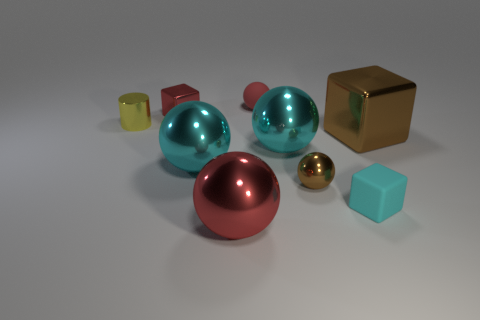Subtract all small brown shiny balls. How many balls are left? 4 Subtract all gray spheres. Subtract all cyan cubes. How many spheres are left? 5 Add 1 shiny cylinders. How many objects exist? 10 Subtract all cylinders. How many objects are left? 8 Subtract all gray spheres. Subtract all tiny red objects. How many objects are left? 7 Add 2 brown spheres. How many brown spheres are left? 3 Add 7 cyan rubber blocks. How many cyan rubber blocks exist? 8 Subtract 0 gray spheres. How many objects are left? 9 